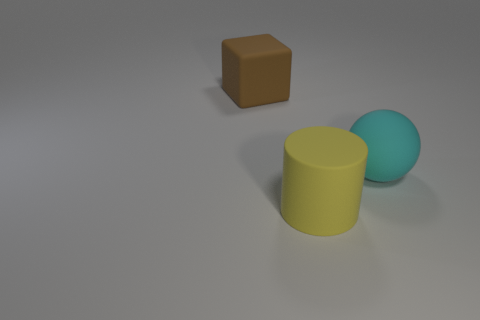Add 3 big gray shiny things. How many objects exist? 6 Add 1 large matte cylinders. How many large matte cylinders are left? 2 Add 2 rubber things. How many rubber things exist? 5 Subtract 0 red cylinders. How many objects are left? 3 Subtract all cylinders. How many objects are left? 2 Subtract all brown spheres. Subtract all purple blocks. How many spheres are left? 1 Subtract all brown cubes. How many gray cylinders are left? 0 Subtract all large yellow rubber spheres. Subtract all large matte things. How many objects are left? 0 